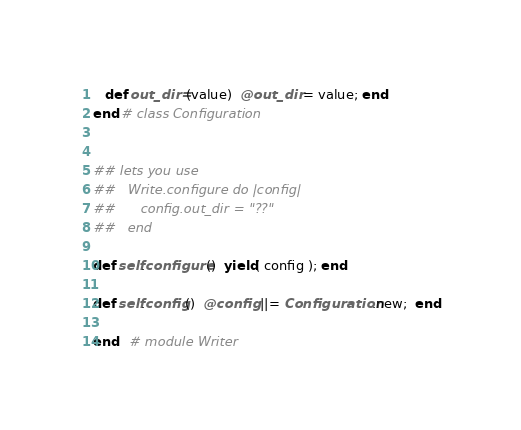<code> <loc_0><loc_0><loc_500><loc_500><_Ruby_>   def out_dir=(value)  @out_dir = value; end
end # class Configuration


## lets you use
##   Write.configure do |config|
##      config.out_dir = "??"
##   end

def self.configure()  yield( config ); end

def self.config()  @config ||= Configuration.new;  end

end   # module Writer</code> 